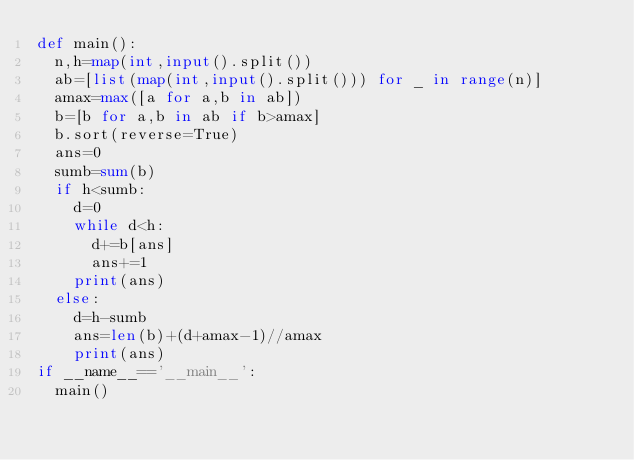Convert code to text. <code><loc_0><loc_0><loc_500><loc_500><_Python_>def main():
  n,h=map(int,input().split())
  ab=[list(map(int,input().split())) for _ in range(n)]
  amax=max([a for a,b in ab])
  b=[b for a,b in ab if b>amax]
  b.sort(reverse=True)
  ans=0
  sumb=sum(b)
  if h<sumb:
    d=0
    while d<h:
      d+=b[ans]
      ans+=1
    print(ans)
  else:
    d=h-sumb
    ans=len(b)+(d+amax-1)//amax 
    print(ans)
if __name__=='__main__':
  main()
</code> 